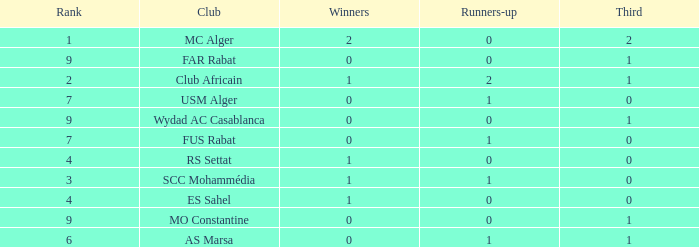Which Third has Runners-up of 0, and Winners of 0, and a Club of far rabat? 1.0. 